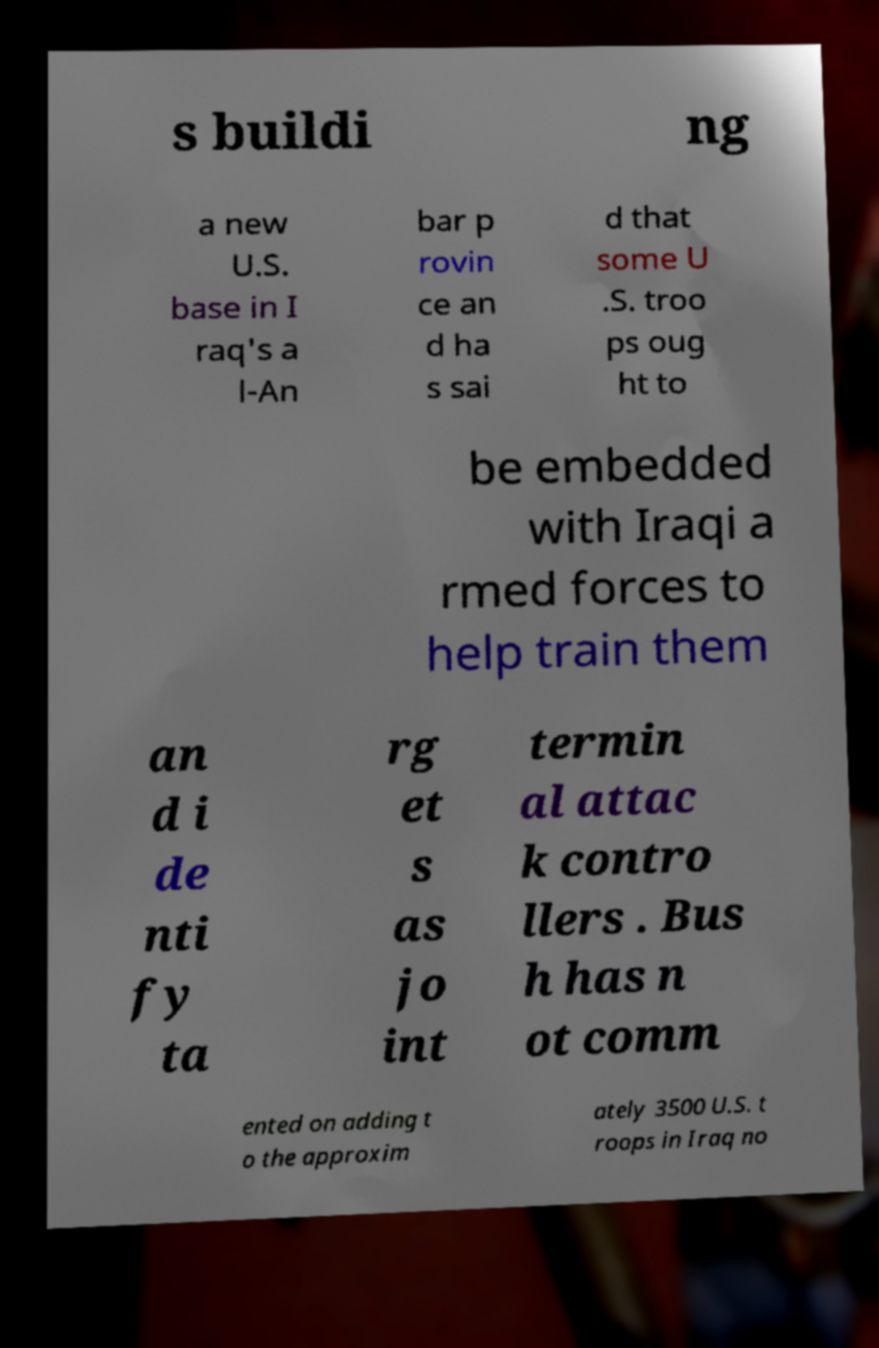For documentation purposes, I need the text within this image transcribed. Could you provide that? s buildi ng a new U.S. base in I raq's a l-An bar p rovin ce an d ha s sai d that some U .S. troo ps oug ht to be embedded with Iraqi a rmed forces to help train them an d i de nti fy ta rg et s as jo int termin al attac k contro llers . Bus h has n ot comm ented on adding t o the approxim ately 3500 U.S. t roops in Iraq no 